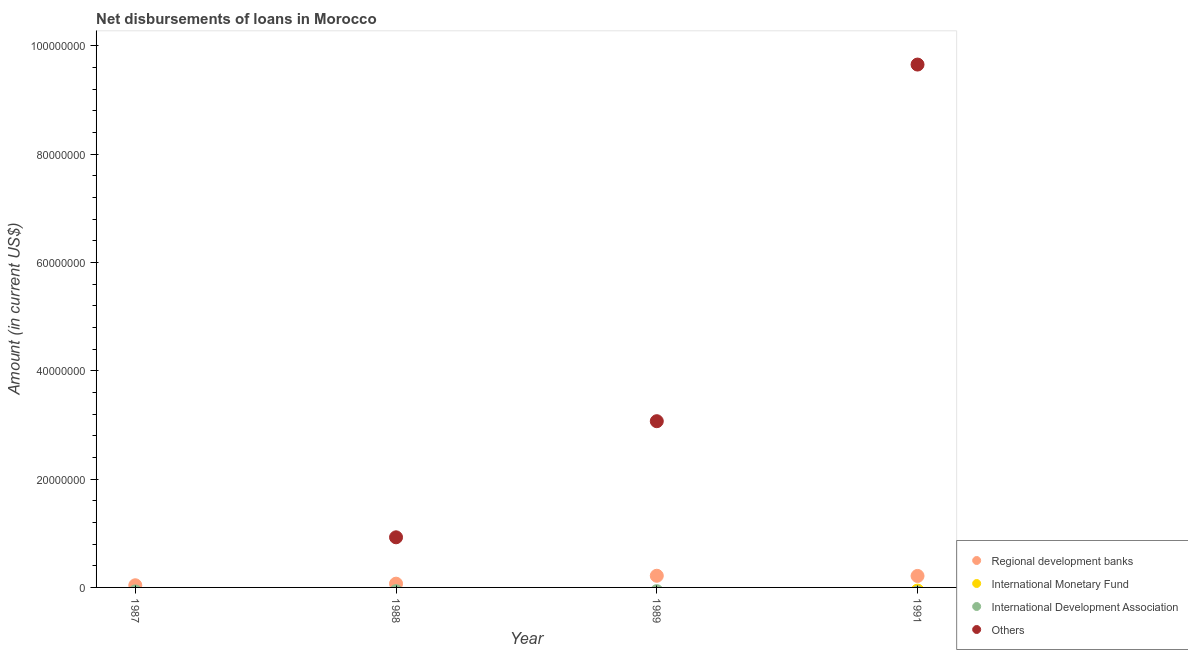Is the number of dotlines equal to the number of legend labels?
Provide a succinct answer. No. Across all years, what is the maximum amount of loan disimbursed by other organisations?
Keep it short and to the point. 9.66e+07. What is the total amount of loan disimbursed by regional development banks in the graph?
Your answer should be very brief. 5.37e+06. What is the difference between the amount of loan disimbursed by other organisations in 1988 and that in 1991?
Give a very brief answer. -8.73e+07. What is the difference between the amount of loan disimbursed by international development association in 1988 and the amount of loan disimbursed by regional development banks in 1991?
Provide a succinct answer. -2.12e+06. What is the average amount of loan disimbursed by other organisations per year?
Provide a short and direct response. 3.41e+07. In the year 1988, what is the difference between the amount of loan disimbursed by regional development banks and amount of loan disimbursed by other organisations?
Provide a short and direct response. -8.56e+06. In how many years, is the amount of loan disimbursed by regional development banks greater than 72000000 US$?
Give a very brief answer. 0. What is the ratio of the amount of loan disimbursed by regional development banks in 1987 to that in 1988?
Offer a very short reply. 0.57. Is the difference between the amount of loan disimbursed by other organisations in 1989 and 1991 greater than the difference between the amount of loan disimbursed by regional development banks in 1989 and 1991?
Keep it short and to the point. No. What is the difference between the highest and the second highest amount of loan disimbursed by regional development banks?
Your answer should be very brief. 3.50e+04. What is the difference between the highest and the lowest amount of loan disimbursed by regional development banks?
Offer a terse response. 1.76e+06. In how many years, is the amount of loan disimbursed by international monetary fund greater than the average amount of loan disimbursed by international monetary fund taken over all years?
Offer a very short reply. 0. Is the sum of the amount of loan disimbursed by regional development banks in 1988 and 1991 greater than the maximum amount of loan disimbursed by international development association across all years?
Ensure brevity in your answer.  Yes. Is it the case that in every year, the sum of the amount of loan disimbursed by other organisations and amount of loan disimbursed by regional development banks is greater than the sum of amount of loan disimbursed by international development association and amount of loan disimbursed by international monetary fund?
Your response must be concise. No. Is it the case that in every year, the sum of the amount of loan disimbursed by regional development banks and amount of loan disimbursed by international monetary fund is greater than the amount of loan disimbursed by international development association?
Give a very brief answer. Yes. Is the amount of loan disimbursed by regional development banks strictly greater than the amount of loan disimbursed by international monetary fund over the years?
Give a very brief answer. Yes. Is the amount of loan disimbursed by international monetary fund strictly less than the amount of loan disimbursed by regional development banks over the years?
Ensure brevity in your answer.  Yes. Are the values on the major ticks of Y-axis written in scientific E-notation?
Offer a terse response. No. What is the title of the graph?
Make the answer very short. Net disbursements of loans in Morocco. Does "Fish species" appear as one of the legend labels in the graph?
Keep it short and to the point. No. What is the label or title of the X-axis?
Keep it short and to the point. Year. What is the Amount (in current US$) in Regional development banks in 1987?
Give a very brief answer. 3.99e+05. What is the Amount (in current US$) in International Monetary Fund in 1987?
Provide a succinct answer. 0. What is the Amount (in current US$) in Others in 1987?
Give a very brief answer. 0. What is the Amount (in current US$) in Regional development banks in 1988?
Provide a short and direct response. 6.94e+05. What is the Amount (in current US$) in Others in 1988?
Provide a succinct answer. 9.26e+06. What is the Amount (in current US$) of Regional development banks in 1989?
Your answer should be compact. 2.16e+06. What is the Amount (in current US$) in International Monetary Fund in 1989?
Your answer should be very brief. 0. What is the Amount (in current US$) of Others in 1989?
Make the answer very short. 3.07e+07. What is the Amount (in current US$) of Regional development banks in 1991?
Keep it short and to the point. 2.12e+06. What is the Amount (in current US$) of International Monetary Fund in 1991?
Ensure brevity in your answer.  0. What is the Amount (in current US$) of Others in 1991?
Keep it short and to the point. 9.66e+07. Across all years, what is the maximum Amount (in current US$) of Regional development banks?
Keep it short and to the point. 2.16e+06. Across all years, what is the maximum Amount (in current US$) of Others?
Your answer should be very brief. 9.66e+07. Across all years, what is the minimum Amount (in current US$) in Regional development banks?
Your answer should be very brief. 3.99e+05. Across all years, what is the minimum Amount (in current US$) in Others?
Provide a succinct answer. 0. What is the total Amount (in current US$) of Regional development banks in the graph?
Your answer should be compact. 5.37e+06. What is the total Amount (in current US$) of International Development Association in the graph?
Your response must be concise. 0. What is the total Amount (in current US$) of Others in the graph?
Offer a terse response. 1.37e+08. What is the difference between the Amount (in current US$) in Regional development banks in 1987 and that in 1988?
Give a very brief answer. -2.95e+05. What is the difference between the Amount (in current US$) in Regional development banks in 1987 and that in 1989?
Offer a terse response. -1.76e+06. What is the difference between the Amount (in current US$) in Regional development banks in 1987 and that in 1991?
Keep it short and to the point. -1.72e+06. What is the difference between the Amount (in current US$) in Regional development banks in 1988 and that in 1989?
Offer a very short reply. -1.46e+06. What is the difference between the Amount (in current US$) in Others in 1988 and that in 1989?
Ensure brevity in your answer.  -2.14e+07. What is the difference between the Amount (in current US$) in Regional development banks in 1988 and that in 1991?
Your response must be concise. -1.43e+06. What is the difference between the Amount (in current US$) of Others in 1988 and that in 1991?
Your answer should be very brief. -8.73e+07. What is the difference between the Amount (in current US$) of Regional development banks in 1989 and that in 1991?
Offer a terse response. 3.50e+04. What is the difference between the Amount (in current US$) in Others in 1989 and that in 1991?
Your answer should be compact. -6.59e+07. What is the difference between the Amount (in current US$) of Regional development banks in 1987 and the Amount (in current US$) of Others in 1988?
Make the answer very short. -8.86e+06. What is the difference between the Amount (in current US$) of Regional development banks in 1987 and the Amount (in current US$) of Others in 1989?
Provide a short and direct response. -3.03e+07. What is the difference between the Amount (in current US$) of Regional development banks in 1987 and the Amount (in current US$) of Others in 1991?
Make the answer very short. -9.62e+07. What is the difference between the Amount (in current US$) of Regional development banks in 1988 and the Amount (in current US$) of Others in 1989?
Provide a succinct answer. -3.00e+07. What is the difference between the Amount (in current US$) of Regional development banks in 1988 and the Amount (in current US$) of Others in 1991?
Keep it short and to the point. -9.59e+07. What is the difference between the Amount (in current US$) of Regional development banks in 1989 and the Amount (in current US$) of Others in 1991?
Your answer should be very brief. -9.44e+07. What is the average Amount (in current US$) in Regional development banks per year?
Make the answer very short. 1.34e+06. What is the average Amount (in current US$) in International Development Association per year?
Ensure brevity in your answer.  0. What is the average Amount (in current US$) in Others per year?
Your response must be concise. 3.41e+07. In the year 1988, what is the difference between the Amount (in current US$) of Regional development banks and Amount (in current US$) of Others?
Provide a short and direct response. -8.56e+06. In the year 1989, what is the difference between the Amount (in current US$) of Regional development banks and Amount (in current US$) of Others?
Offer a terse response. -2.85e+07. In the year 1991, what is the difference between the Amount (in current US$) of Regional development banks and Amount (in current US$) of Others?
Your response must be concise. -9.44e+07. What is the ratio of the Amount (in current US$) of Regional development banks in 1987 to that in 1988?
Make the answer very short. 0.57. What is the ratio of the Amount (in current US$) of Regional development banks in 1987 to that in 1989?
Your response must be concise. 0.19. What is the ratio of the Amount (in current US$) in Regional development banks in 1987 to that in 1991?
Ensure brevity in your answer.  0.19. What is the ratio of the Amount (in current US$) of Regional development banks in 1988 to that in 1989?
Offer a terse response. 0.32. What is the ratio of the Amount (in current US$) in Others in 1988 to that in 1989?
Ensure brevity in your answer.  0.3. What is the ratio of the Amount (in current US$) of Regional development banks in 1988 to that in 1991?
Provide a succinct answer. 0.33. What is the ratio of the Amount (in current US$) in Others in 1988 to that in 1991?
Ensure brevity in your answer.  0.1. What is the ratio of the Amount (in current US$) of Regional development banks in 1989 to that in 1991?
Your response must be concise. 1.02. What is the ratio of the Amount (in current US$) of Others in 1989 to that in 1991?
Provide a short and direct response. 0.32. What is the difference between the highest and the second highest Amount (in current US$) of Regional development banks?
Ensure brevity in your answer.  3.50e+04. What is the difference between the highest and the second highest Amount (in current US$) in Others?
Give a very brief answer. 6.59e+07. What is the difference between the highest and the lowest Amount (in current US$) of Regional development banks?
Give a very brief answer. 1.76e+06. What is the difference between the highest and the lowest Amount (in current US$) of Others?
Offer a terse response. 9.66e+07. 